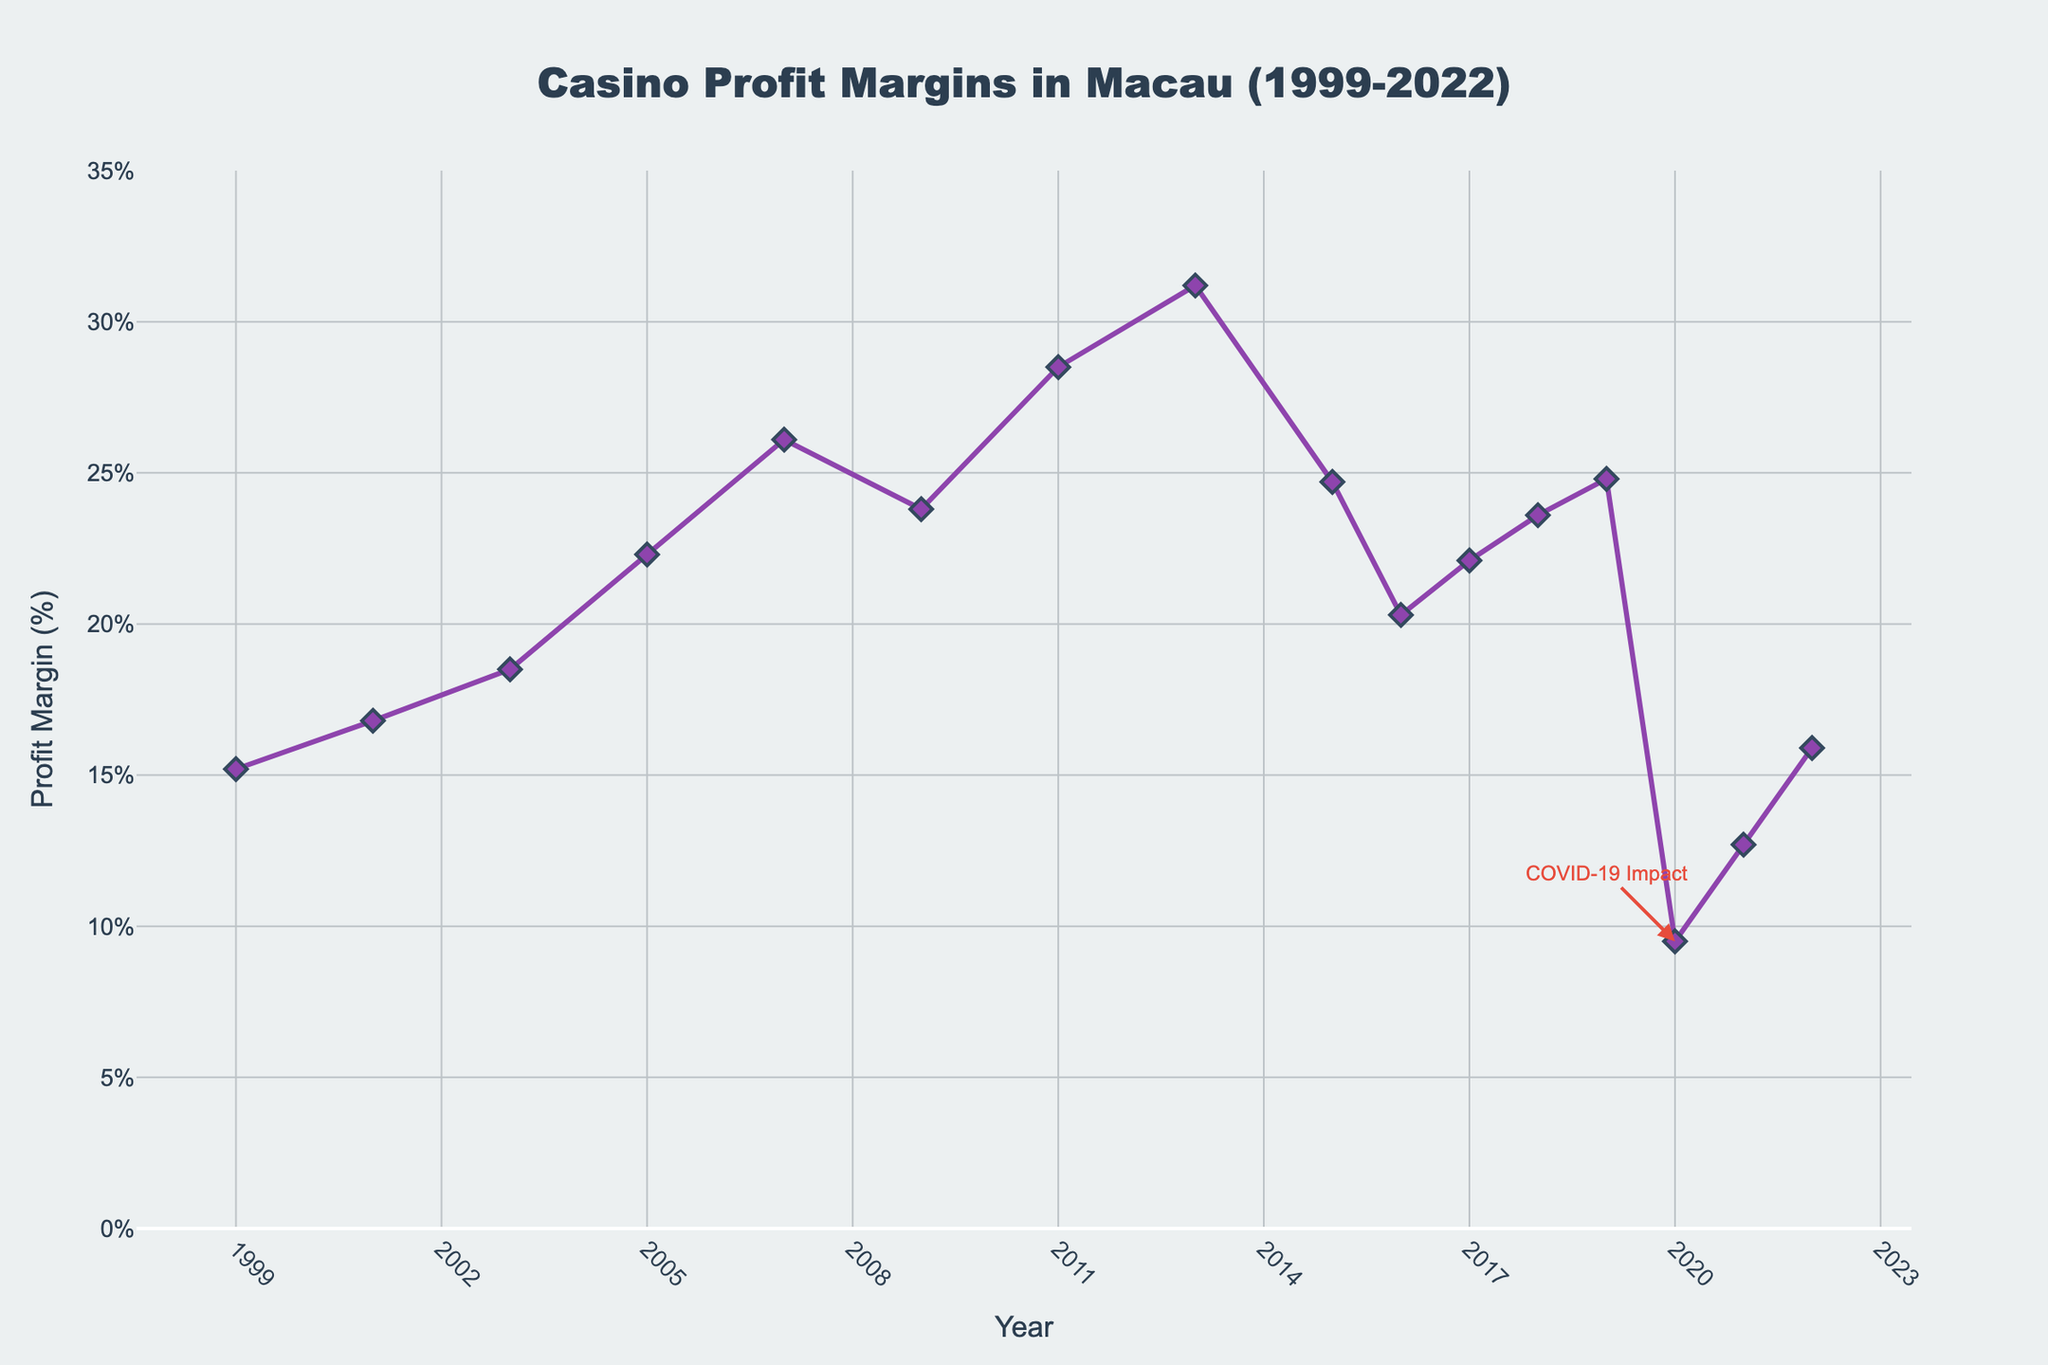What was the profit margin for casinos in Macau in 1999? The data point directly shows the profit margin for 1999 at 15.2%.
Answer: 15.2% In which year did the casinos in Macau achieve the highest profit margin, and what was the percentage? Observing the line chart, the highest peak occurs in 2013 with a profit margin of 31.2%.
Answer: 2013, 31.2% How did the profit margin change from 2007 to 2009? The profit margin decreased from 26.1% in 2007 to 23.8% in 2009. The change is a difference of 26.1% - 23.8% = 2.3%.
Answer: Decreased by 2.3% What is the average profit margin from 2015 to 2019? The profit margins from 2015 to 2019 are 24.7%, 20.3%, 22.1%, 23.6%, and 24.8%. Adding these up: 24.7 + 20.3 + 22.1 + 23.6 + 24.8 = 115.5. Dividing by 5, the average is 115.5 / 5 = 23.1%.
Answer: 23.1% What was the percentage drop in profit margin from 2019 to 2020? The profit margin dropped from 24.8% in 2019 to 9.5% in 2020. The difference is 24.8% - 9.5% = 15.3%.
Answer: 15.3% What does the annotation near the 2020 data point indicate? The annotation near the 2020 data point indicates the "COVID-19 Impact." Observing the drastic drop to 9.5% around 2020 helps identify the impact visually.
Answer: COVID-19 Impact Compare the profit margins in 2001 and 2007. Which year had a higher profit margin and by how much? In 2001, the profit margin was 16.8%, and in 2007, it was 26.1%. 26.1% - 16.8% = 9.3%, so 2007 had a higher profit margin by 9.3%.
Answer: 2007, 9.3% What is the trend in profit margins between 2003 and 2013? Observing the chart, the profit margins generally increase from 18.5% in 2003 to 31.2% in 2013, signifying an upward trend.
Answer: Upward trend Is there any year between 1999 and 2022 where the profit margin was below 10%? Based on the line chart, only the year 2020 shows a profit margin below 10%, specifically at 9.5%.
Answer: 2020 